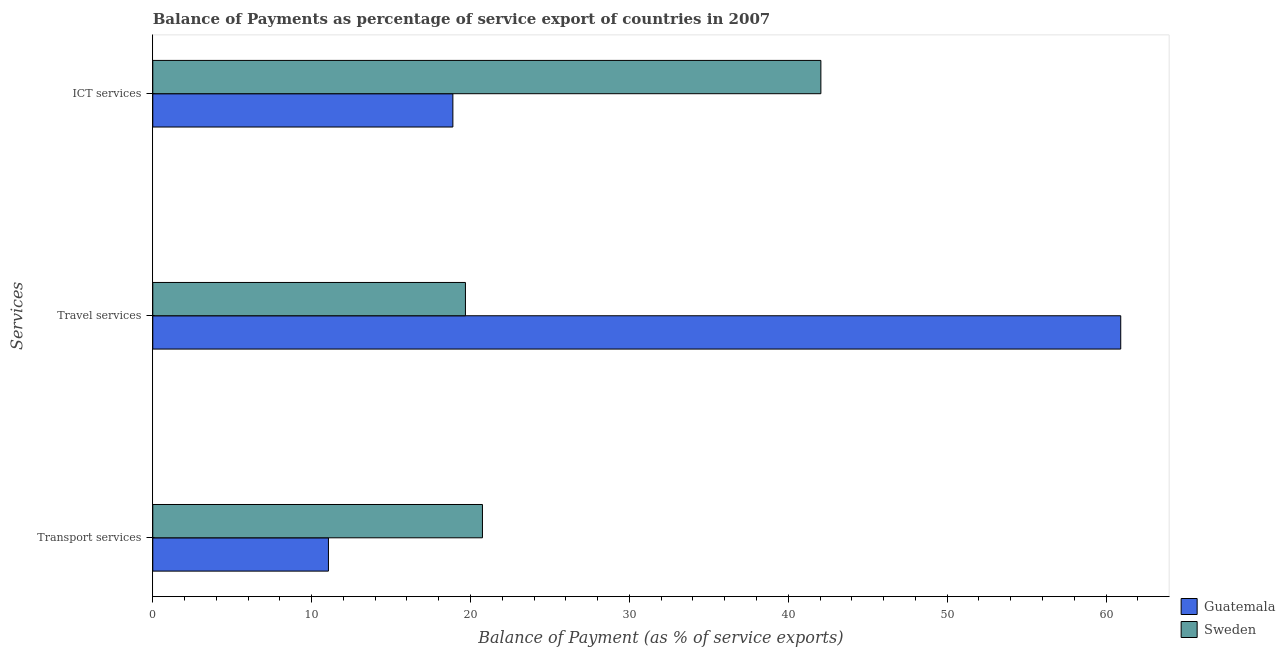How many different coloured bars are there?
Your answer should be very brief. 2. How many groups of bars are there?
Ensure brevity in your answer.  3. Are the number of bars on each tick of the Y-axis equal?
Your answer should be very brief. Yes. How many bars are there on the 1st tick from the top?
Keep it short and to the point. 2. What is the label of the 2nd group of bars from the top?
Ensure brevity in your answer.  Travel services. What is the balance of payment of transport services in Guatemala?
Your answer should be very brief. 11.06. Across all countries, what is the maximum balance of payment of transport services?
Your answer should be compact. 20.75. Across all countries, what is the minimum balance of payment of travel services?
Provide a succinct answer. 19.68. In which country was the balance of payment of travel services maximum?
Offer a very short reply. Guatemala. In which country was the balance of payment of ict services minimum?
Ensure brevity in your answer.  Guatemala. What is the total balance of payment of travel services in the graph?
Keep it short and to the point. 80.6. What is the difference between the balance of payment of travel services in Guatemala and that in Sweden?
Provide a succinct answer. 41.24. What is the difference between the balance of payment of travel services in Sweden and the balance of payment of transport services in Guatemala?
Your answer should be very brief. 8.62. What is the average balance of payment of ict services per country?
Give a very brief answer. 30.47. What is the difference between the balance of payment of ict services and balance of payment of travel services in Sweden?
Your answer should be compact. 22.37. In how many countries, is the balance of payment of travel services greater than 14 %?
Provide a short and direct response. 2. What is the ratio of the balance of payment of transport services in Guatemala to that in Sweden?
Provide a short and direct response. 0.53. What is the difference between the highest and the second highest balance of payment of ict services?
Give a very brief answer. 23.16. What is the difference between the highest and the lowest balance of payment of transport services?
Give a very brief answer. 9.69. What does the 2nd bar from the top in Transport services represents?
Give a very brief answer. Guatemala. What does the 2nd bar from the bottom in Transport services represents?
Your answer should be very brief. Sweden. Is it the case that in every country, the sum of the balance of payment of transport services and balance of payment of travel services is greater than the balance of payment of ict services?
Provide a short and direct response. No. How many bars are there?
Keep it short and to the point. 6. Are all the bars in the graph horizontal?
Give a very brief answer. Yes. How many countries are there in the graph?
Ensure brevity in your answer.  2. What is the difference between two consecutive major ticks on the X-axis?
Your answer should be very brief. 10. Does the graph contain any zero values?
Your answer should be very brief. No. Does the graph contain grids?
Ensure brevity in your answer.  No. How many legend labels are there?
Give a very brief answer. 2. How are the legend labels stacked?
Provide a short and direct response. Vertical. What is the title of the graph?
Ensure brevity in your answer.  Balance of Payments as percentage of service export of countries in 2007. Does "Iran" appear as one of the legend labels in the graph?
Ensure brevity in your answer.  No. What is the label or title of the X-axis?
Provide a short and direct response. Balance of Payment (as % of service exports). What is the label or title of the Y-axis?
Keep it short and to the point. Services. What is the Balance of Payment (as % of service exports) of Guatemala in Transport services?
Ensure brevity in your answer.  11.06. What is the Balance of Payment (as % of service exports) in Sweden in Transport services?
Your answer should be compact. 20.75. What is the Balance of Payment (as % of service exports) in Guatemala in Travel services?
Your answer should be compact. 60.92. What is the Balance of Payment (as % of service exports) of Sweden in Travel services?
Ensure brevity in your answer.  19.68. What is the Balance of Payment (as % of service exports) in Guatemala in ICT services?
Offer a terse response. 18.89. What is the Balance of Payment (as % of service exports) in Sweden in ICT services?
Your answer should be very brief. 42.05. Across all Services, what is the maximum Balance of Payment (as % of service exports) in Guatemala?
Offer a terse response. 60.92. Across all Services, what is the maximum Balance of Payment (as % of service exports) in Sweden?
Your response must be concise. 42.05. Across all Services, what is the minimum Balance of Payment (as % of service exports) in Guatemala?
Your answer should be compact. 11.06. Across all Services, what is the minimum Balance of Payment (as % of service exports) in Sweden?
Offer a terse response. 19.68. What is the total Balance of Payment (as % of service exports) in Guatemala in the graph?
Provide a short and direct response. 90.87. What is the total Balance of Payment (as % of service exports) of Sweden in the graph?
Make the answer very short. 82.48. What is the difference between the Balance of Payment (as % of service exports) in Guatemala in Transport services and that in Travel services?
Offer a very short reply. -49.87. What is the difference between the Balance of Payment (as % of service exports) in Sweden in Transport services and that in Travel services?
Offer a terse response. 1.07. What is the difference between the Balance of Payment (as % of service exports) of Guatemala in Transport services and that in ICT services?
Provide a succinct answer. -7.83. What is the difference between the Balance of Payment (as % of service exports) of Sweden in Transport services and that in ICT services?
Your response must be concise. -21.3. What is the difference between the Balance of Payment (as % of service exports) of Guatemala in Travel services and that in ICT services?
Provide a short and direct response. 42.03. What is the difference between the Balance of Payment (as % of service exports) in Sweden in Travel services and that in ICT services?
Keep it short and to the point. -22.37. What is the difference between the Balance of Payment (as % of service exports) in Guatemala in Transport services and the Balance of Payment (as % of service exports) in Sweden in Travel services?
Your response must be concise. -8.62. What is the difference between the Balance of Payment (as % of service exports) in Guatemala in Transport services and the Balance of Payment (as % of service exports) in Sweden in ICT services?
Provide a succinct answer. -30.99. What is the difference between the Balance of Payment (as % of service exports) of Guatemala in Travel services and the Balance of Payment (as % of service exports) of Sweden in ICT services?
Make the answer very short. 18.87. What is the average Balance of Payment (as % of service exports) in Guatemala per Services?
Ensure brevity in your answer.  30.29. What is the average Balance of Payment (as % of service exports) in Sweden per Services?
Provide a succinct answer. 27.49. What is the difference between the Balance of Payment (as % of service exports) of Guatemala and Balance of Payment (as % of service exports) of Sweden in Transport services?
Provide a short and direct response. -9.69. What is the difference between the Balance of Payment (as % of service exports) in Guatemala and Balance of Payment (as % of service exports) in Sweden in Travel services?
Provide a short and direct response. 41.24. What is the difference between the Balance of Payment (as % of service exports) of Guatemala and Balance of Payment (as % of service exports) of Sweden in ICT services?
Your response must be concise. -23.16. What is the ratio of the Balance of Payment (as % of service exports) of Guatemala in Transport services to that in Travel services?
Ensure brevity in your answer.  0.18. What is the ratio of the Balance of Payment (as % of service exports) of Sweden in Transport services to that in Travel services?
Provide a short and direct response. 1.05. What is the ratio of the Balance of Payment (as % of service exports) of Guatemala in Transport services to that in ICT services?
Make the answer very short. 0.59. What is the ratio of the Balance of Payment (as % of service exports) of Sweden in Transport services to that in ICT services?
Provide a succinct answer. 0.49. What is the ratio of the Balance of Payment (as % of service exports) of Guatemala in Travel services to that in ICT services?
Provide a short and direct response. 3.23. What is the ratio of the Balance of Payment (as % of service exports) of Sweden in Travel services to that in ICT services?
Provide a short and direct response. 0.47. What is the difference between the highest and the second highest Balance of Payment (as % of service exports) of Guatemala?
Your response must be concise. 42.03. What is the difference between the highest and the second highest Balance of Payment (as % of service exports) of Sweden?
Your response must be concise. 21.3. What is the difference between the highest and the lowest Balance of Payment (as % of service exports) in Guatemala?
Ensure brevity in your answer.  49.87. What is the difference between the highest and the lowest Balance of Payment (as % of service exports) of Sweden?
Your answer should be compact. 22.37. 